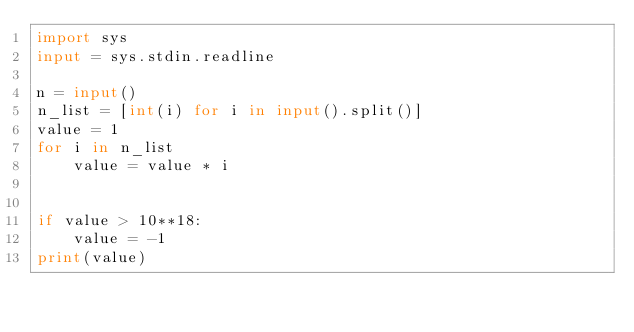Convert code to text. <code><loc_0><loc_0><loc_500><loc_500><_Python_>import sys
input = sys.stdin.readline

n = input()
n_list = [int(i) for i in input().split()]
value = 1
for i in n_list
    value = value * i


if value > 10**18:
    value = -1
print(value)</code> 